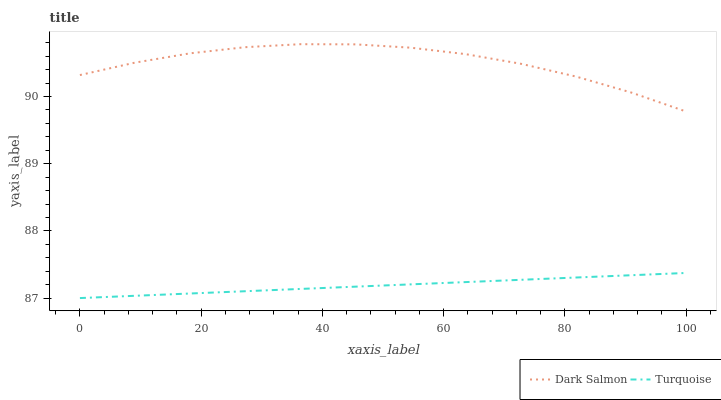Does Turquoise have the minimum area under the curve?
Answer yes or no. Yes. Does Dark Salmon have the maximum area under the curve?
Answer yes or no. Yes. Does Dark Salmon have the minimum area under the curve?
Answer yes or no. No. Is Turquoise the smoothest?
Answer yes or no. Yes. Is Dark Salmon the roughest?
Answer yes or no. Yes. Is Dark Salmon the smoothest?
Answer yes or no. No. Does Turquoise have the lowest value?
Answer yes or no. Yes. Does Dark Salmon have the lowest value?
Answer yes or no. No. Does Dark Salmon have the highest value?
Answer yes or no. Yes. Is Turquoise less than Dark Salmon?
Answer yes or no. Yes. Is Dark Salmon greater than Turquoise?
Answer yes or no. Yes. Does Turquoise intersect Dark Salmon?
Answer yes or no. No. 